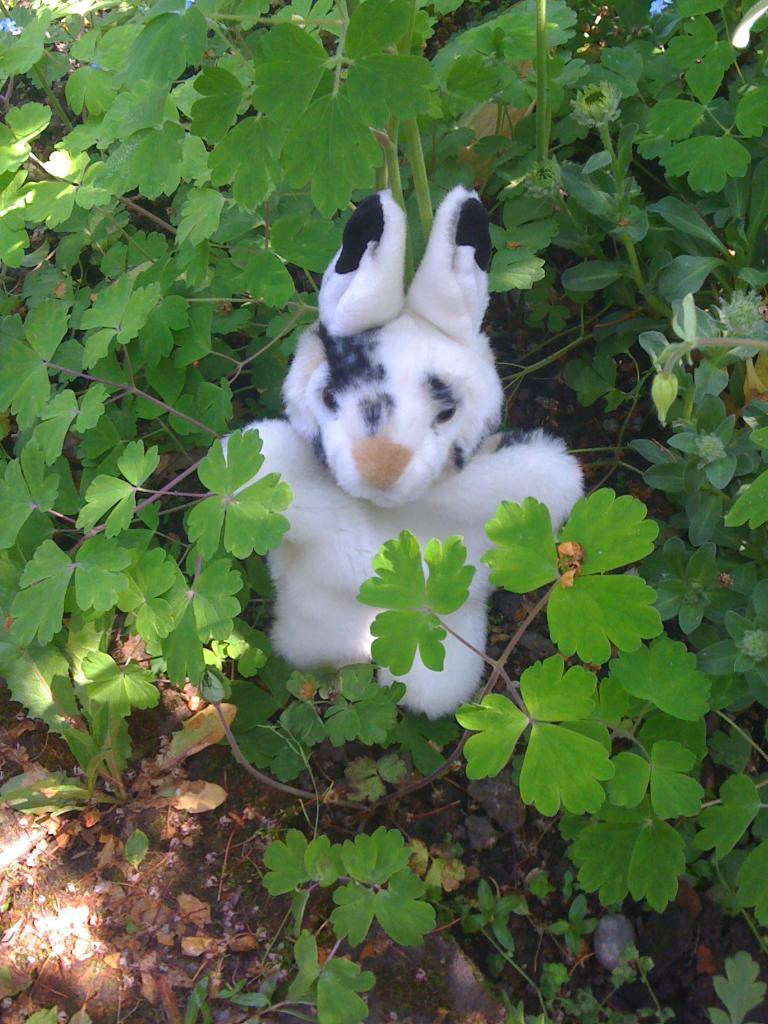What type of living organisms can be seen in the image? Plants can be seen in the image. What is the appearance of the doll in the image? There is a white doll with black color in the image. What is the condition of the path in the image? There is a path with mud in the image. What type of support is the doll using to stand in the image? The doll does not require any support to stand in the image, as it is likely a static object. 